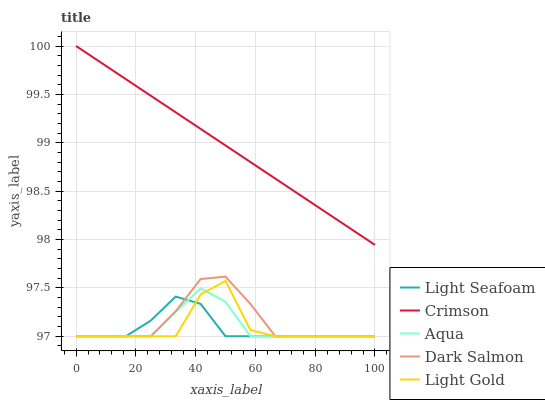Does Light Gold have the minimum area under the curve?
Answer yes or no. No. Does Light Gold have the maximum area under the curve?
Answer yes or no. No. Is Light Seafoam the smoothest?
Answer yes or no. No. Is Light Seafoam the roughest?
Answer yes or no. No. Does Light Gold have the highest value?
Answer yes or no. No. Is Light Gold less than Crimson?
Answer yes or no. Yes. Is Crimson greater than Dark Salmon?
Answer yes or no. Yes. Does Light Gold intersect Crimson?
Answer yes or no. No. 